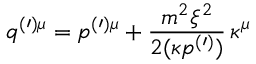<formula> <loc_0><loc_0><loc_500><loc_500>q ^ { ( \prime ) \mu } = p ^ { ( \prime ) \mu } + \frac { m ^ { 2 } \xi ^ { 2 } } { 2 ( \kappa p ^ { ( \prime ) } ) } \, \kappa ^ { \mu }</formula> 